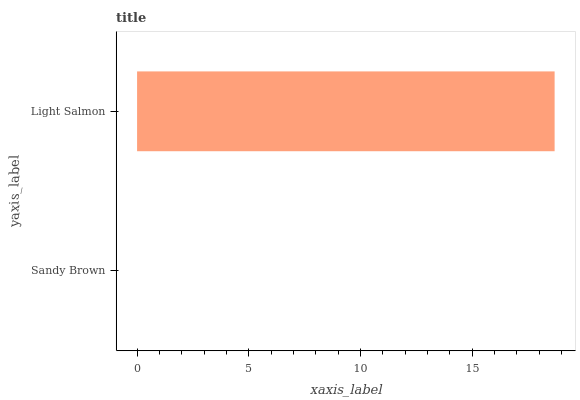Is Sandy Brown the minimum?
Answer yes or no. Yes. Is Light Salmon the maximum?
Answer yes or no. Yes. Is Light Salmon the minimum?
Answer yes or no. No. Is Light Salmon greater than Sandy Brown?
Answer yes or no. Yes. Is Sandy Brown less than Light Salmon?
Answer yes or no. Yes. Is Sandy Brown greater than Light Salmon?
Answer yes or no. No. Is Light Salmon less than Sandy Brown?
Answer yes or no. No. Is Light Salmon the high median?
Answer yes or no. Yes. Is Sandy Brown the low median?
Answer yes or no. Yes. Is Sandy Brown the high median?
Answer yes or no. No. Is Light Salmon the low median?
Answer yes or no. No. 